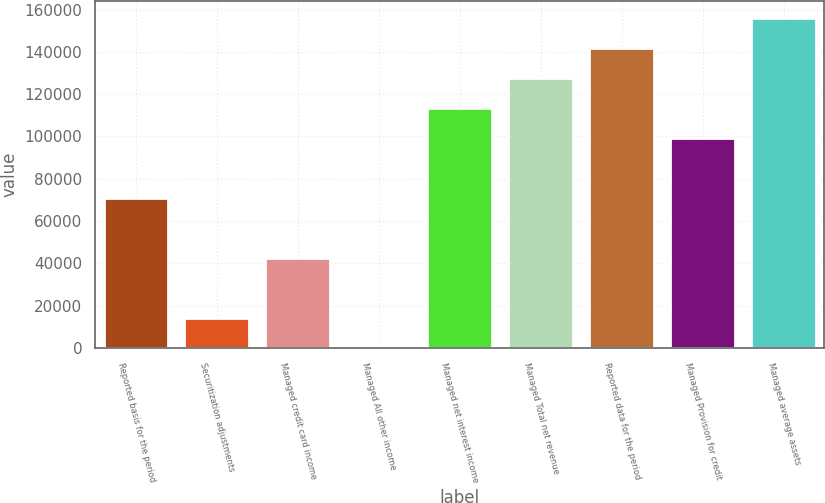Convert chart. <chart><loc_0><loc_0><loc_500><loc_500><bar_chart><fcel>Reported basis for the period<fcel>Securitization adjustments<fcel>Managed credit card income<fcel>Managed All other income<fcel>Managed net interest income<fcel>Managed Total net revenue<fcel>Reported data for the period<fcel>Managed Provision for credit<fcel>Managed average assets<nl><fcel>71072.5<fcel>14384.1<fcel>42728.3<fcel>212<fcel>113589<fcel>127761<fcel>141933<fcel>99416.7<fcel>156105<nl></chart> 